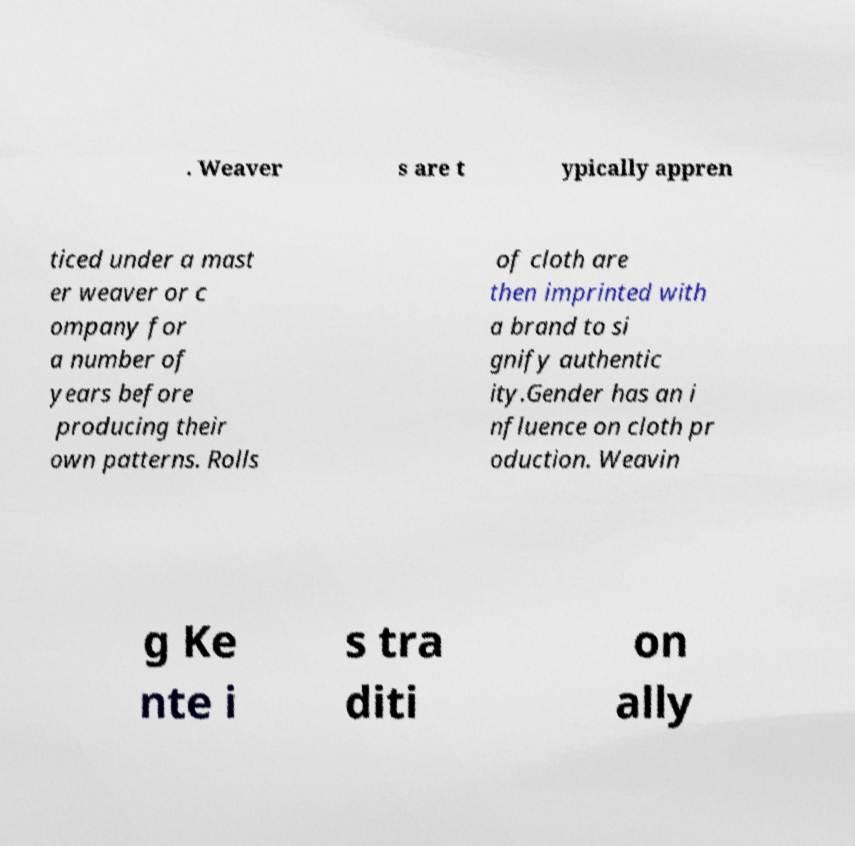Can you read and provide the text displayed in the image?This photo seems to have some interesting text. Can you extract and type it out for me? . Weaver s are t ypically appren ticed under a mast er weaver or c ompany for a number of years before producing their own patterns. Rolls of cloth are then imprinted with a brand to si gnify authentic ity.Gender has an i nfluence on cloth pr oduction. Weavin g Ke nte i s tra diti on ally 